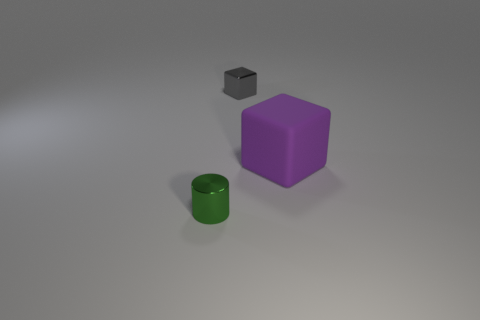There is a object that is the same size as the green shiny cylinder; what is it made of?
Provide a short and direct response. Metal. How many other objects are there of the same material as the purple block?
Your answer should be compact. 0. There is a metal cube; is its size the same as the rubber cube that is to the right of the green metal object?
Your answer should be compact. No. Is the number of metallic cylinders that are right of the small block less than the number of green things that are behind the tiny green shiny object?
Your answer should be very brief. No. There is a metallic thing behind the large matte block; what is its size?
Offer a very short reply. Small. Is the size of the purple object the same as the metallic cylinder?
Provide a short and direct response. No. What number of things are left of the tiny gray metallic thing and on the right side of the small gray metallic thing?
Ensure brevity in your answer.  0. How many green objects are either tiny shiny cubes or cylinders?
Provide a short and direct response. 1. What number of metal things are small cylinders or large things?
Make the answer very short. 1. Are there any blocks?
Provide a succinct answer. Yes. 